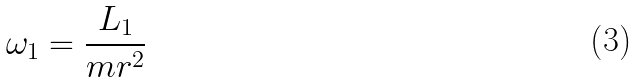<formula> <loc_0><loc_0><loc_500><loc_500>\omega _ { 1 } = \frac { L _ { 1 } } { m r ^ { 2 } }</formula> 